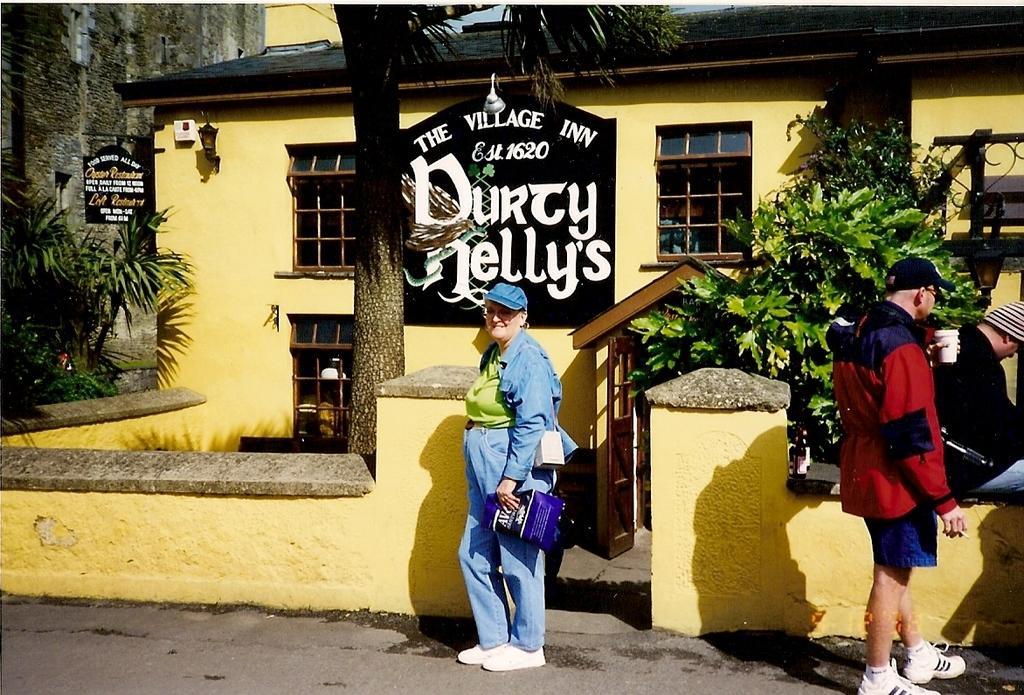Describe this image in one or two sentences. In the middle of the image few people are standing and holding some cups and bags. Behind them there is wall. Behind the wall there are some trees and plants and buildings. 